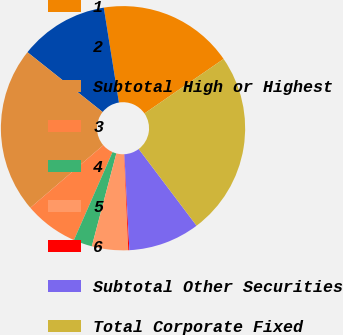Convert chart to OTSL. <chart><loc_0><loc_0><loc_500><loc_500><pie_chart><fcel>1<fcel>2<fcel>Subtotal High or Highest<fcel>3<fcel>4<fcel>5<fcel>6<fcel>Subtotal Other Securities<fcel>Total Corporate Fixed<nl><fcel>17.92%<fcel>11.79%<fcel>21.98%<fcel>7.13%<fcel>2.47%<fcel>4.8%<fcel>0.14%<fcel>9.46%<fcel>24.31%<nl></chart> 